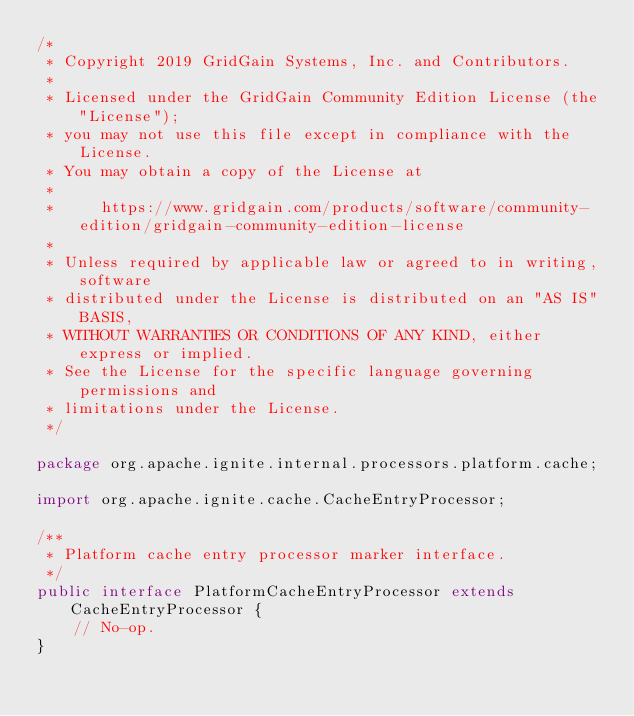Convert code to text. <code><loc_0><loc_0><loc_500><loc_500><_Java_>/*
 * Copyright 2019 GridGain Systems, Inc. and Contributors.
 *
 * Licensed under the GridGain Community Edition License (the "License");
 * you may not use this file except in compliance with the License.
 * You may obtain a copy of the License at
 *
 *     https://www.gridgain.com/products/software/community-edition/gridgain-community-edition-license
 *
 * Unless required by applicable law or agreed to in writing, software
 * distributed under the License is distributed on an "AS IS" BASIS,
 * WITHOUT WARRANTIES OR CONDITIONS OF ANY KIND, either express or implied.
 * See the License for the specific language governing permissions and
 * limitations under the License.
 */

package org.apache.ignite.internal.processors.platform.cache;

import org.apache.ignite.cache.CacheEntryProcessor;

/**
 * Platform cache entry processor marker interface.
 */
public interface PlatformCacheEntryProcessor extends CacheEntryProcessor {
    // No-op.
}
</code> 